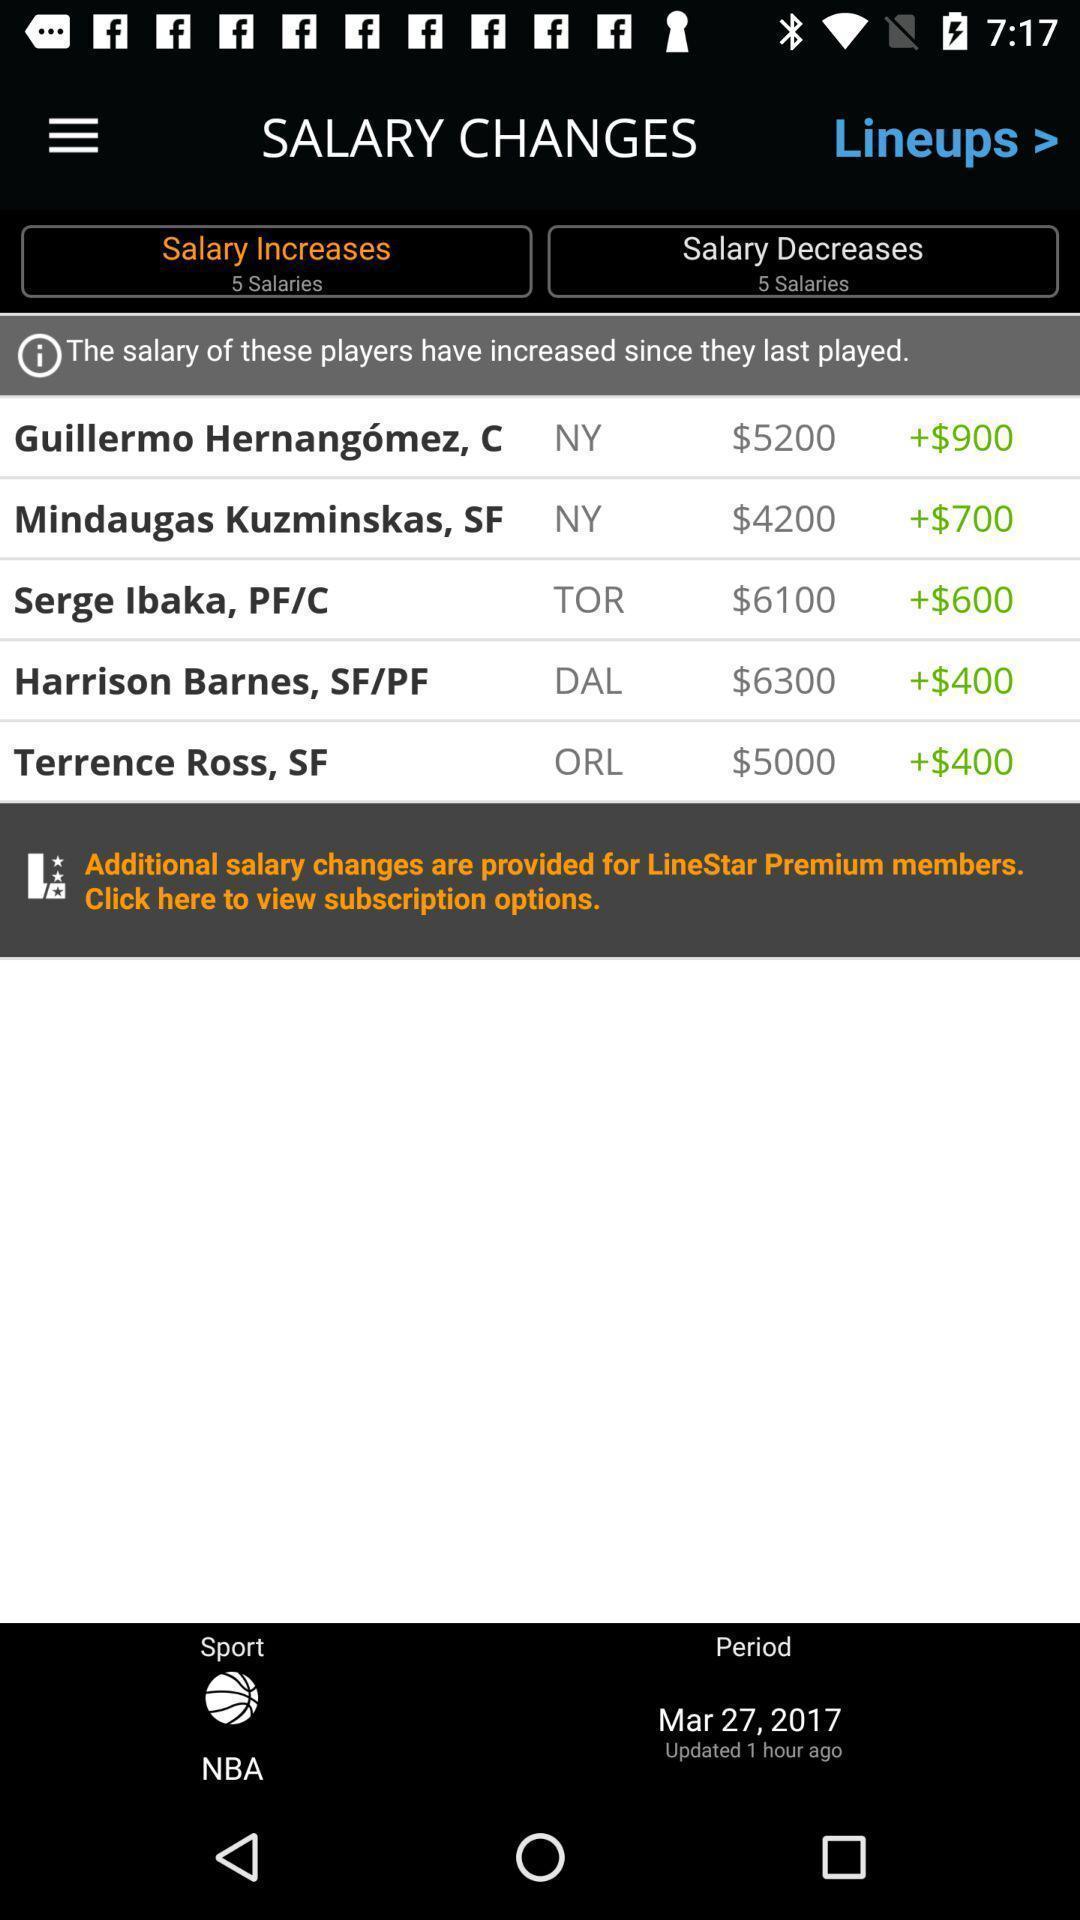Give me a summary of this screen capture. Salary information displaying in this page. 